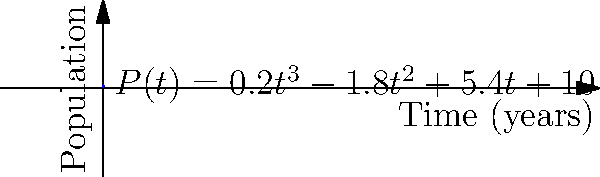As part of an international treaty negotiation on wildlife protection, you're presented with a cubic polynomial model for the population growth of an endangered species: $P(t) = 0.2t^3 - 1.8t^2 + 5.4t + 10$, where $P(t)$ represents the population after $t$ years. At what point in time does the population reach its minimum value according to this model? To find the minimum point of the population, we need to follow these steps:

1) The minimum point occurs where the derivative of the function equals zero. Let's find the derivative:
   $P'(t) = 0.6t^2 - 3.6t + 5.4$

2) Set the derivative equal to zero:
   $0.6t^2 - 3.6t + 5.4 = 0$

3) This is a quadratic equation. We can solve it using the quadratic formula:
   $t = \frac{-b \pm \sqrt{b^2 - 4ac}}{2a}$

   Where $a = 0.6$, $b = -3.6$, and $c = 5.4$

4) Plugging in these values:
   $t = \frac{3.6 \pm \sqrt{(-3.6)^2 - 4(0.6)(5.4)}}{2(0.6)}$

5) Simplifying:
   $t = \frac{3.6 \pm \sqrt{12.96 - 12.96}}{1.2} = \frac{3.6 \pm 0}{1.2} = 3$

6) The single solution $t = 3$ indicates that this is the point where the function changes from decreasing to increasing, i.e., the minimum point.

Therefore, the population reaches its minimum value after 3 years.
Answer: 3 years 